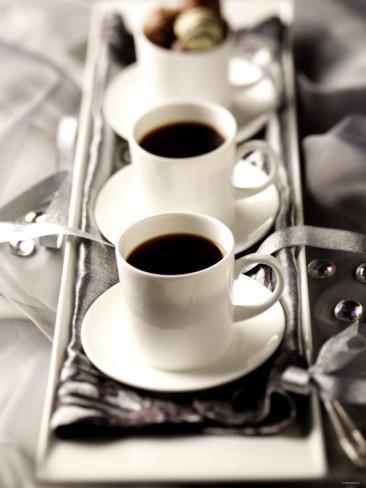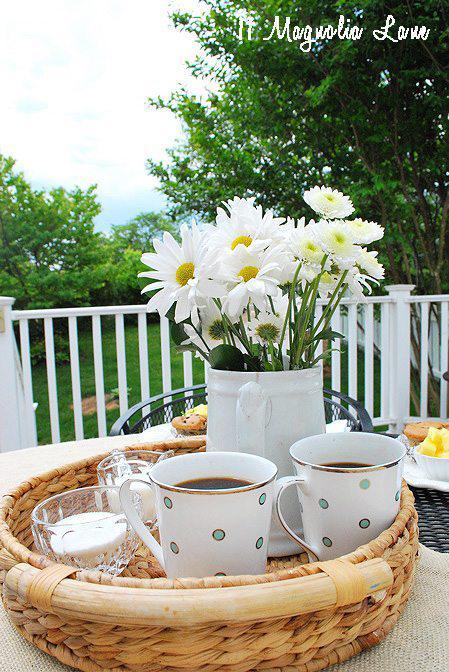The first image is the image on the left, the second image is the image on the right. For the images shown, is this caption "In one image, a bouquet of flowers is near two cups of coffee, while the second image shows one or more cups of coffee with matching saucers." true? Answer yes or no. Yes. The first image is the image on the left, the second image is the image on the right. Assess this claim about the two images: "An image shows a container of fresh flowers and a tray containing two filled beverage cups.". Correct or not? Answer yes or no. Yes. 